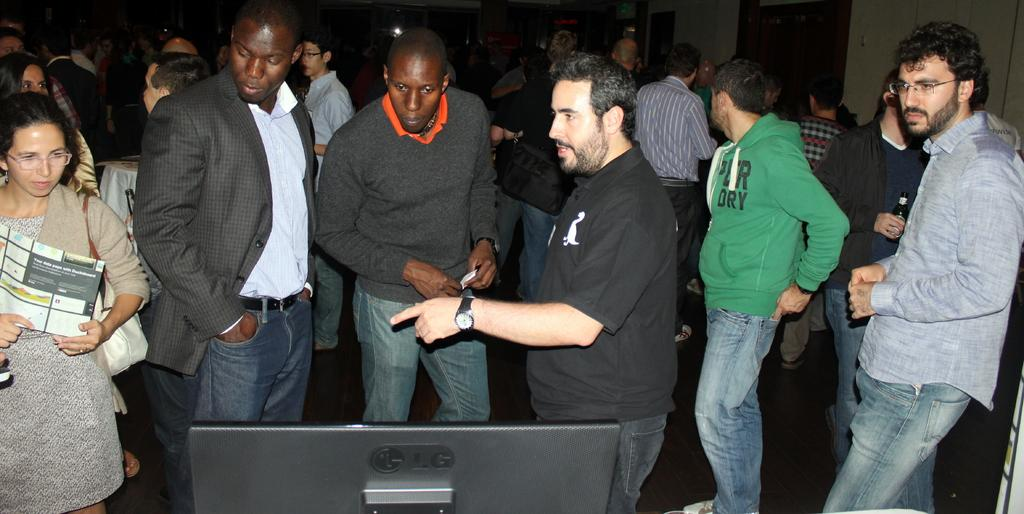How many people are in the image? There is a group of people standing in the image. What is the surface they are standing on? The people are standing on the floor. What electronic device can be seen in the image? There is a monitor in the image. What type of object is visible in the image that might contain a liquid? There is a bottle in the image. What type of object is visible in the image that might contain written information? There is a paper in the image. What can be seen in the background of the image? There is a wall visible in the background of the image. How many receipts are visible in the image? There are no receipts visible in the image. Can you describe the kissing scene in the image? There is no kissing scene present in the image. 